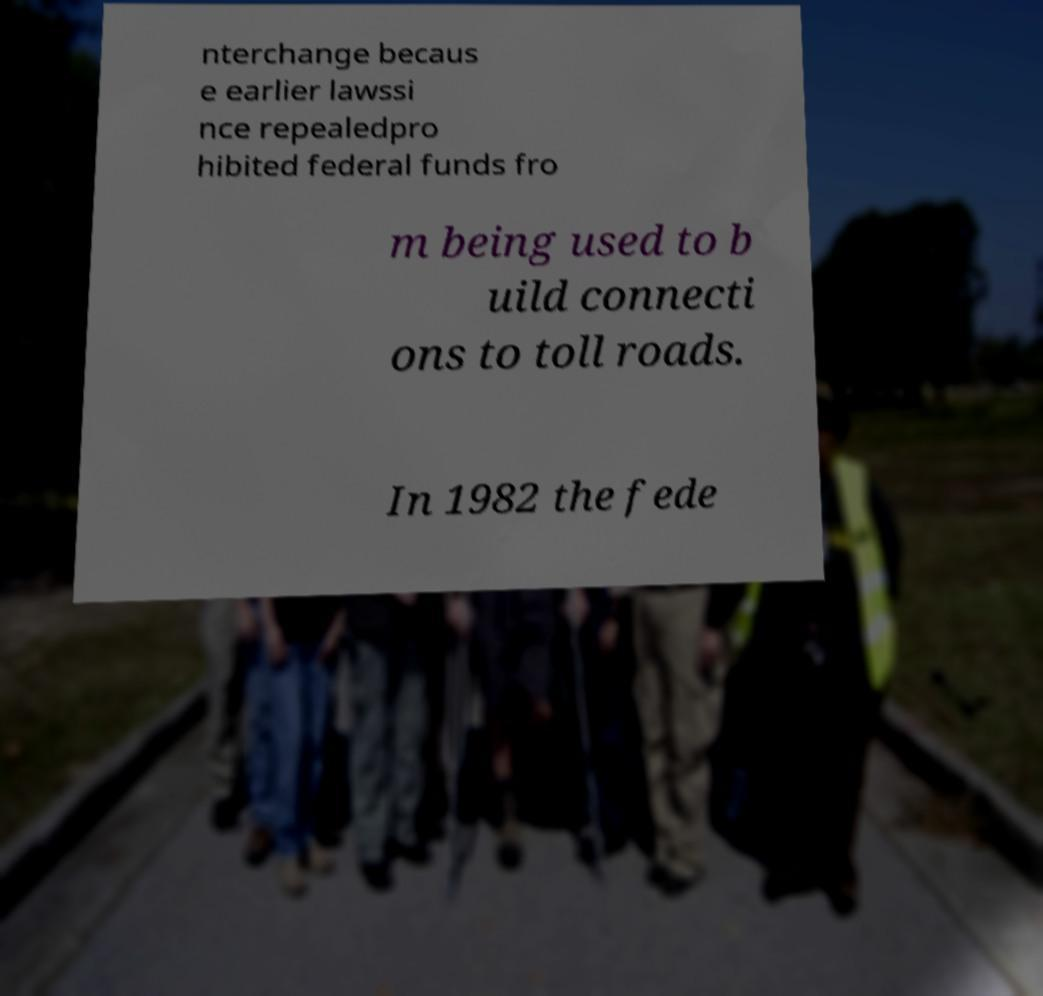Could you extract and type out the text from this image? nterchange becaus e earlier lawssi nce repealedpro hibited federal funds fro m being used to b uild connecti ons to toll roads. In 1982 the fede 